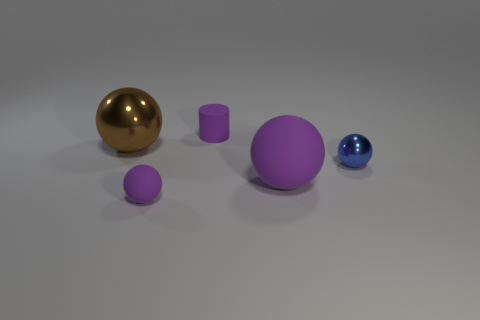How many small objects are either purple metallic cylinders or purple cylinders?
Ensure brevity in your answer.  1. Are there the same number of big brown metal objects to the left of the small cylinder and purple objects?
Give a very brief answer. No. Is there a small matte cylinder that is right of the purple object behind the small shiny object?
Offer a terse response. No. How many other objects are the same color as the cylinder?
Your answer should be compact. 2. The large rubber ball has what color?
Keep it short and to the point. Purple. What is the size of the object that is both behind the blue metallic ball and on the left side of the small purple cylinder?
Keep it short and to the point. Large. What number of objects are either large things to the right of the cylinder or blocks?
Make the answer very short. 1. There is a small object that is the same material as the cylinder; what is its shape?
Ensure brevity in your answer.  Sphere. The large metal thing is what shape?
Your answer should be compact. Sphere. The rubber thing that is both in front of the matte cylinder and right of the tiny matte sphere is what color?
Your answer should be very brief. Purple. 